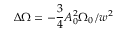<formula> <loc_0><loc_0><loc_500><loc_500>\Delta \Omega = - \frac { 3 } { 4 } A _ { 0 } ^ { 2 } \Omega _ { 0 } / w ^ { 2 }</formula> 